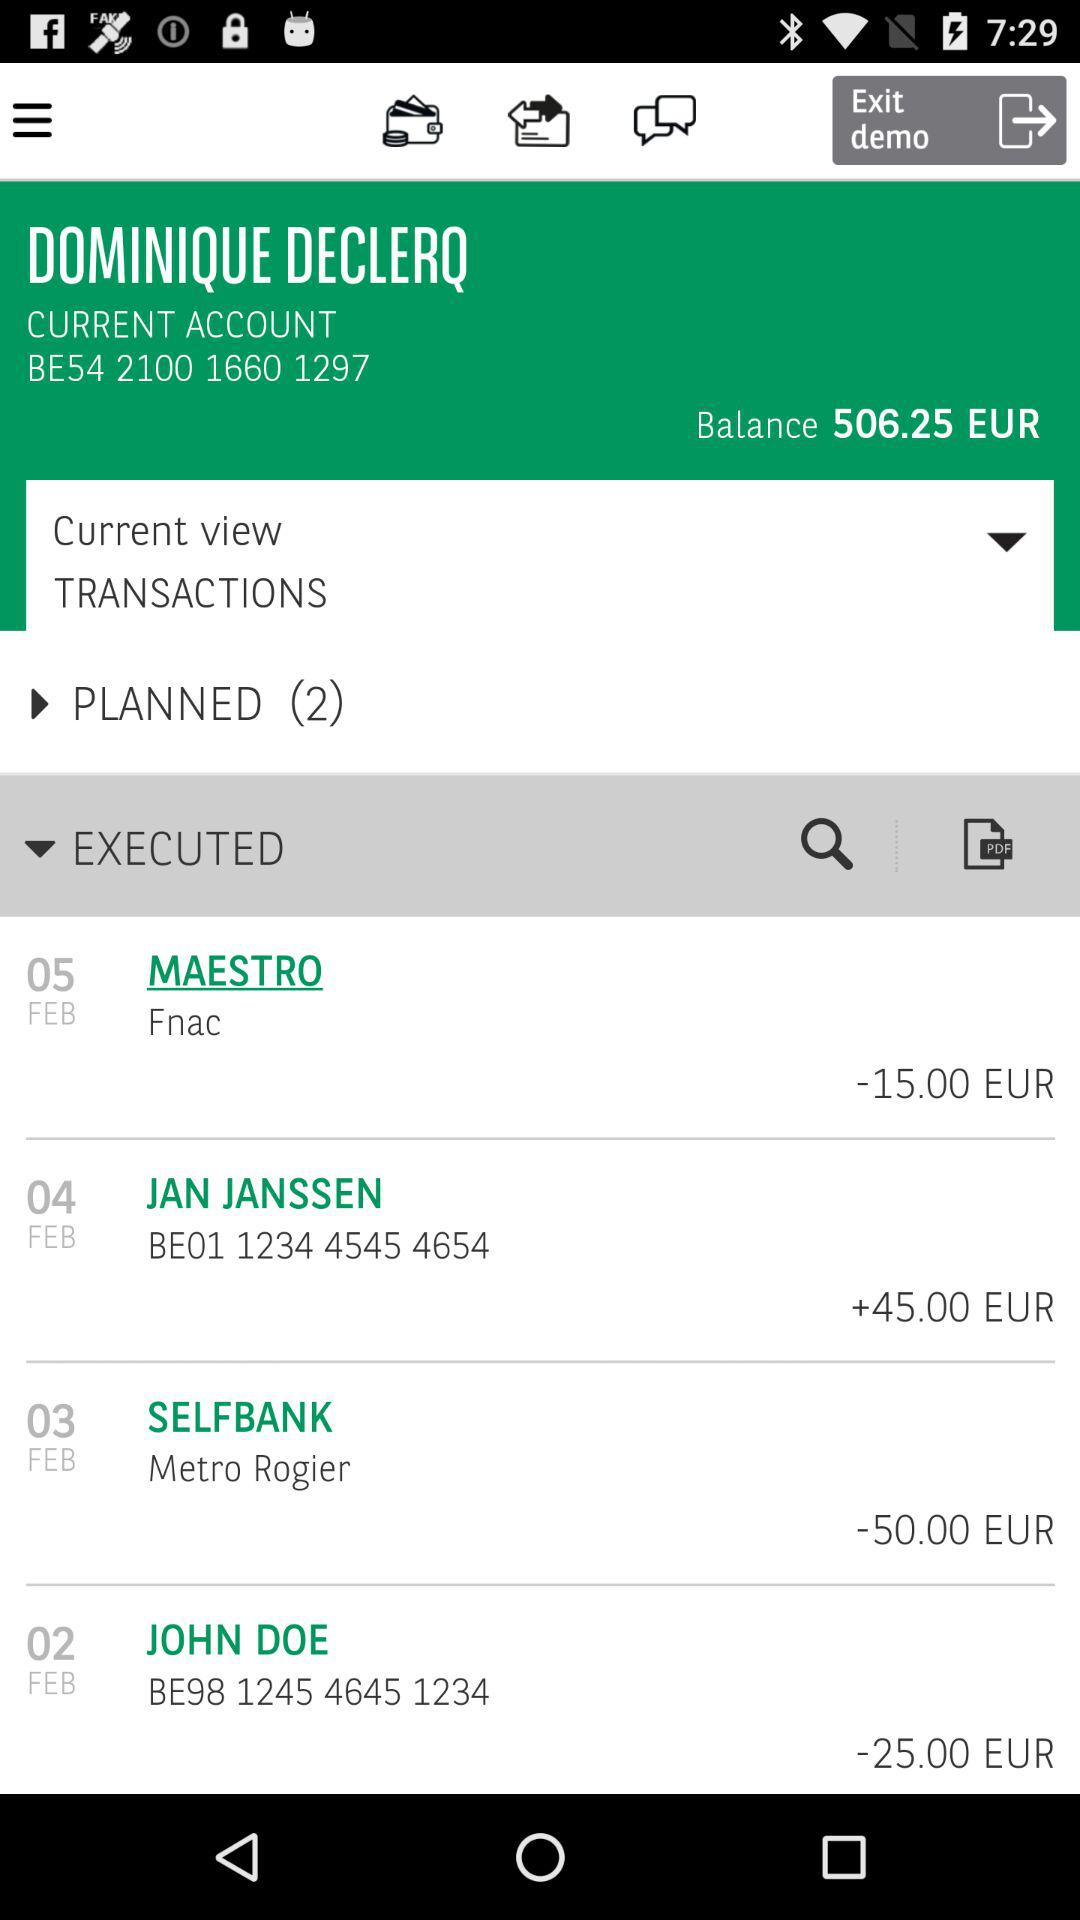How much money was spent on the transaction with the highest amount?
Answer the question using a single word or phrase. -50.00 EUR 